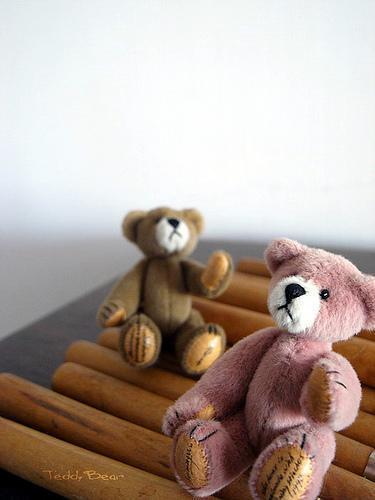How many teddy bears are in the photo?
Give a very brief answer. 2. How many cars are there?
Give a very brief answer. 0. 